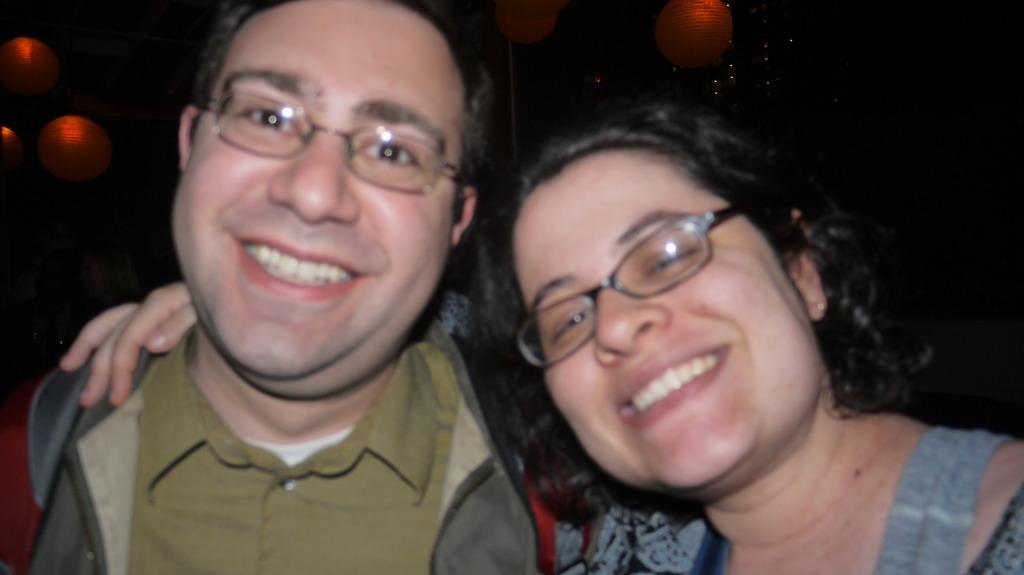Please provide a concise description of this image. In this image we can see two people smiling and posing for a photo and in the background, we can see some lights. 